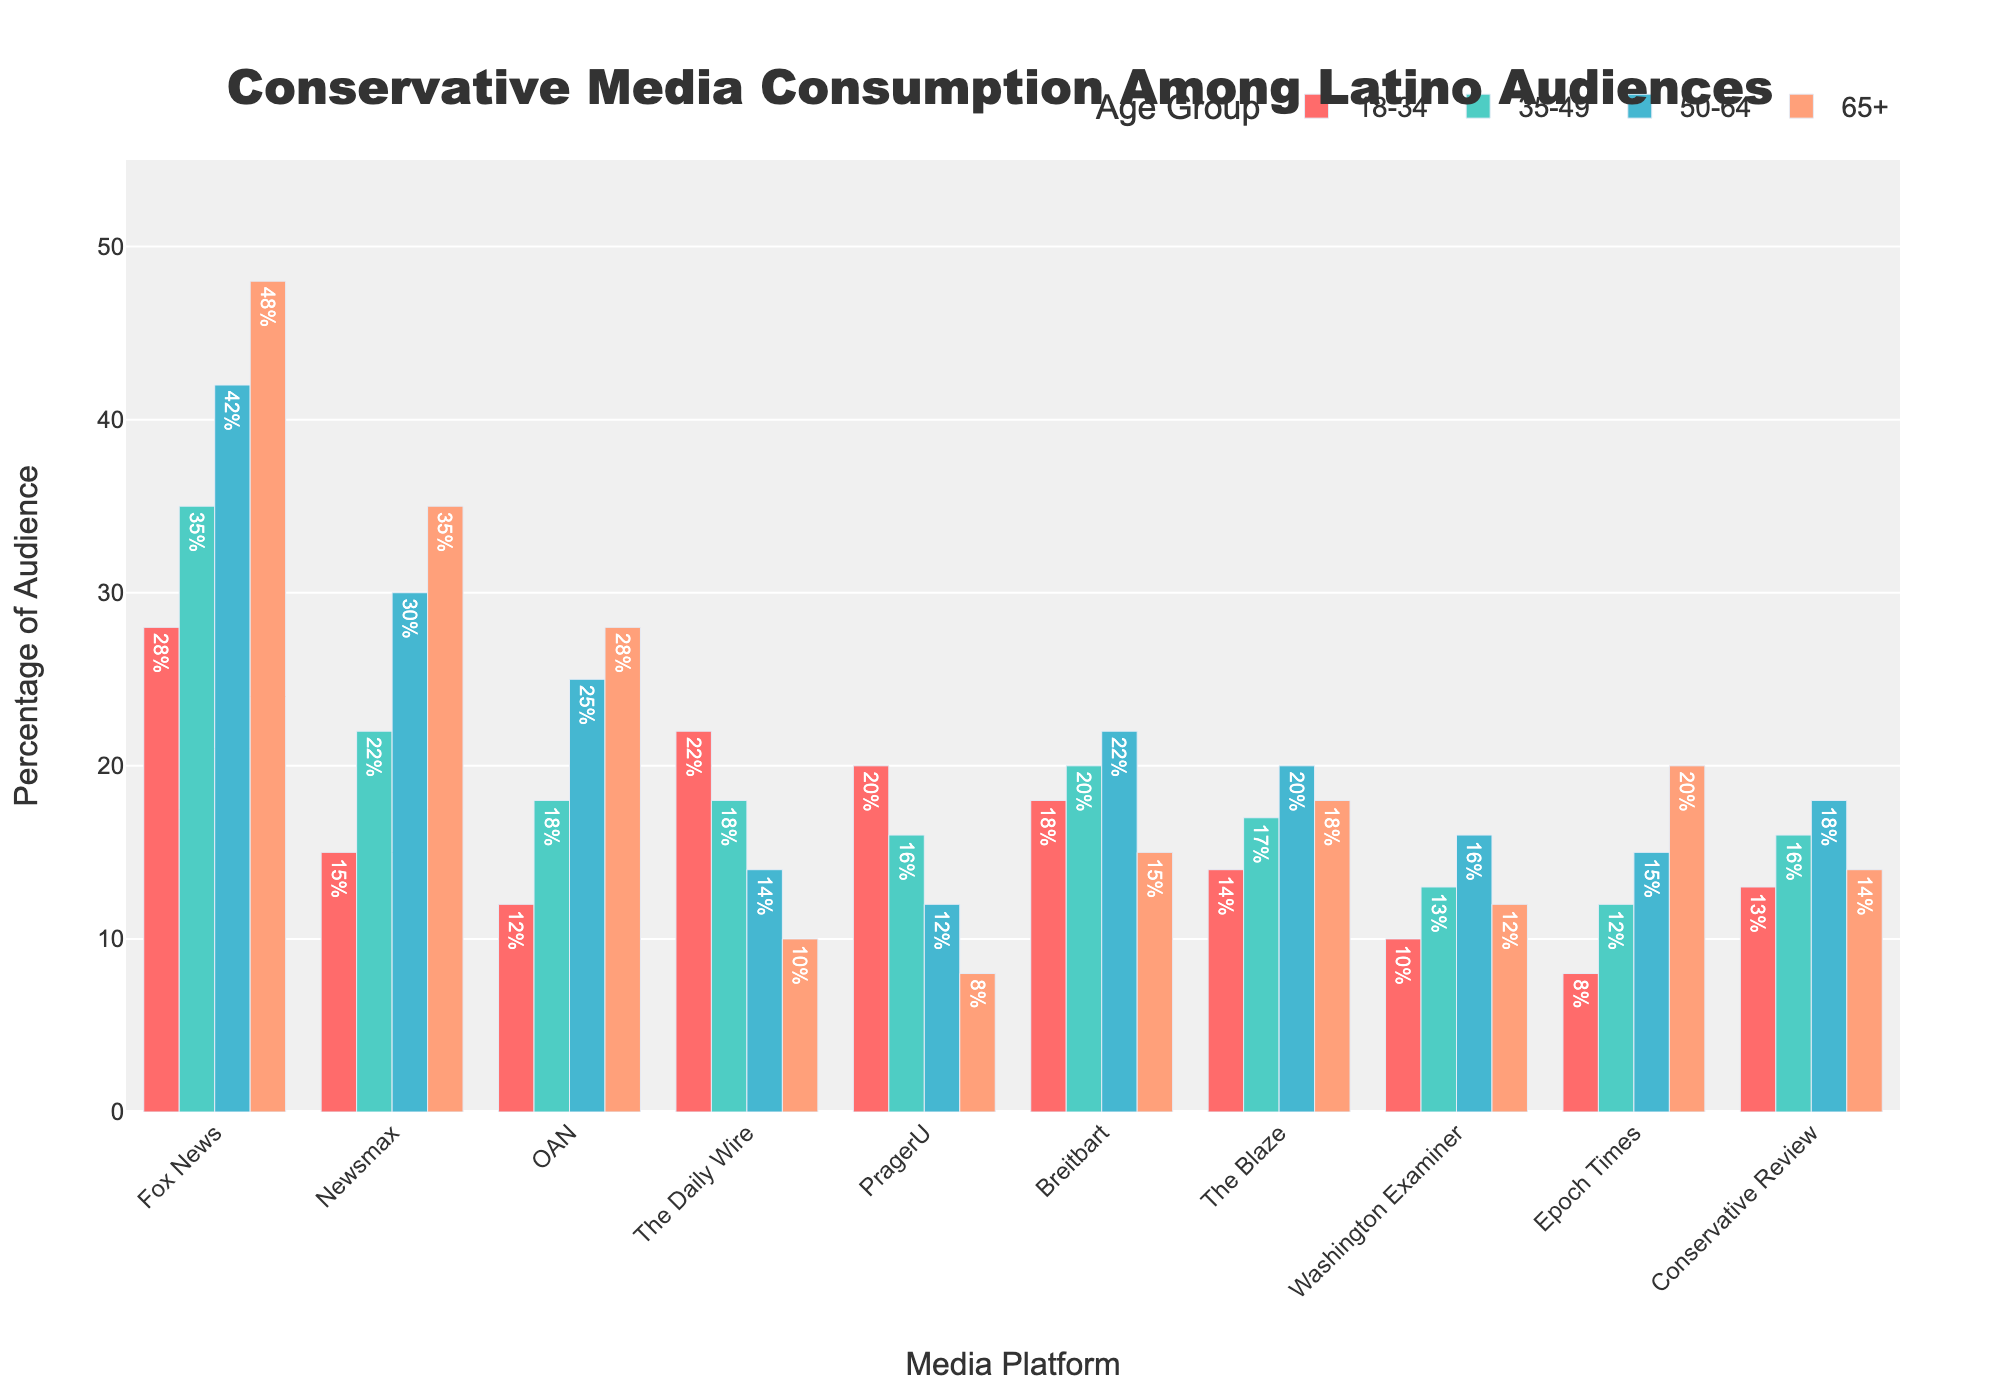Which platform has the highest percentage of audience aged 18-34? Look for the tallest bar among the age group 18-34. The tallest bar is for Fox News with a percentage of 28%.
Answer: Fox News Which age group has the lowest percentage of viewers for PragerU? Look for the shortest bar within the PragerU category. The shortest bar is for the age group 65+ with a percentage of 8%.
Answer: 65+ What is the difference in audience percentage between The Blaze and Epoch Times for the age group 50-64? Refer to the bars for The Blaze and Epoch Times in the age group 50-64. The Blaze has 20% and Epoch Times has 15%, so the difference is 20% - 15% = 5%.
Answer: 5% How much higher is the percentage of viewers aged 65+ for Fox News compared to The Daily Wire? Find the bars for Fox News and The Daily Wire in the age group 65+. Fox News has 48% and The Daily Wire has 10%, so 48% - 10% = 38%.
Answer: 38% What is the average percentage of audience aged 35-49 across all platforms? Add the percentages for the age group 35-49 across all platforms and then divide by the number of platforms: (35 + 22 + 18 + 18 + 16 + 20 + 17 + 13 + 12 + 16) / 10 = 18.7%.
Answer: 18.7% Which platform has the most equal distribution across all age groups? Compare the height of the bars for each platform to see which one has bars of similar height. Conservative Review has relatively equal bars (13%, 16%, 18%, 14%).
Answer: Conservative Review For the age group 50-64, which platform has a percentage closest to 20%? Look for the platforms with percentages close to 20% for the age group 50-64. The Blaze, with 20%, is the closest.
Answer: The Blaze What is the combined audience percentage for Newsmax and OAN among the age group 35-49? Sum the percentages for Newsmax and OAN within the age group 35-49: 22% + 18% = 40%.
Answer: 40% How does the audience percentage for Fox News in the age group 18-34 compare to that for 65+? Compare the height of the bars for Fox News in these age groups. Fox News has 28% for 18-34 and 48% for 65+, so it is 20% higher for 65+.
Answer: 20% Which platform has the lowest overall audience percentage in the age group 50-64? Identify the shortest bar among all platforms in the age group 50-64. Epoch Times has the lowest percentage with 15%.
Answer: Epoch Times 